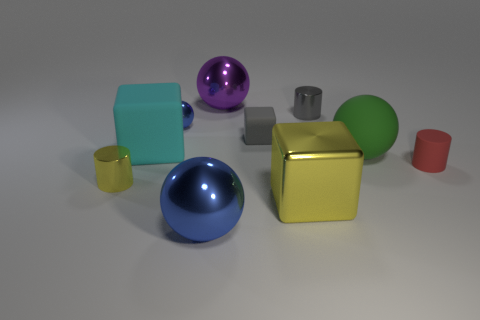Subtract all small blue metal spheres. How many spheres are left? 3 Subtract all yellow blocks. How many blocks are left? 2 Subtract all green blocks. How many blue spheres are left? 2 Subtract 2 cubes. How many cubes are left? 1 Subtract all balls. How many objects are left? 6 Subtract all blue cylinders. Subtract all green blocks. How many cylinders are left? 3 Subtract all small brown metallic objects. Subtract all tiny gray matte blocks. How many objects are left? 9 Add 9 small gray blocks. How many small gray blocks are left? 10 Add 3 cyan matte cubes. How many cyan matte cubes exist? 4 Subtract 0 purple blocks. How many objects are left? 10 